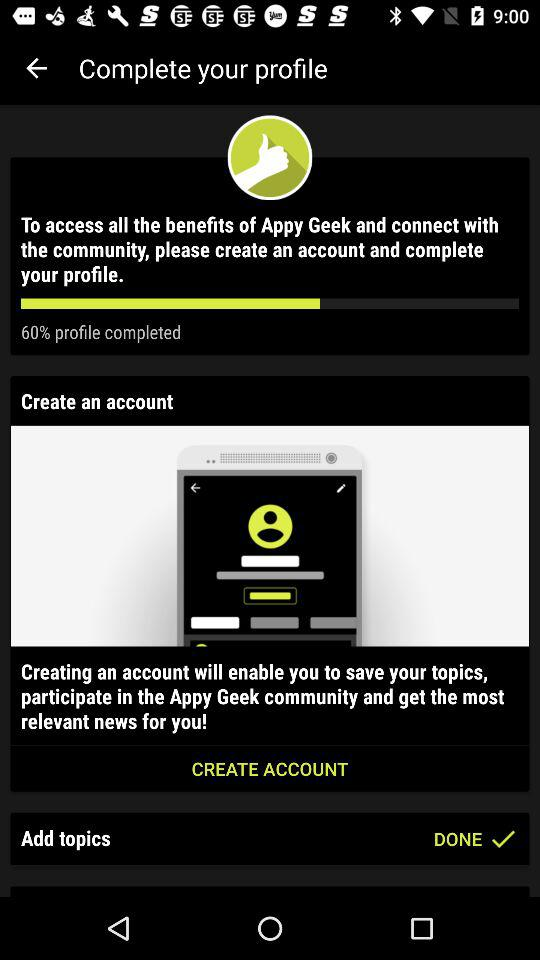What is the application name? The application name is "Appy Geek". 